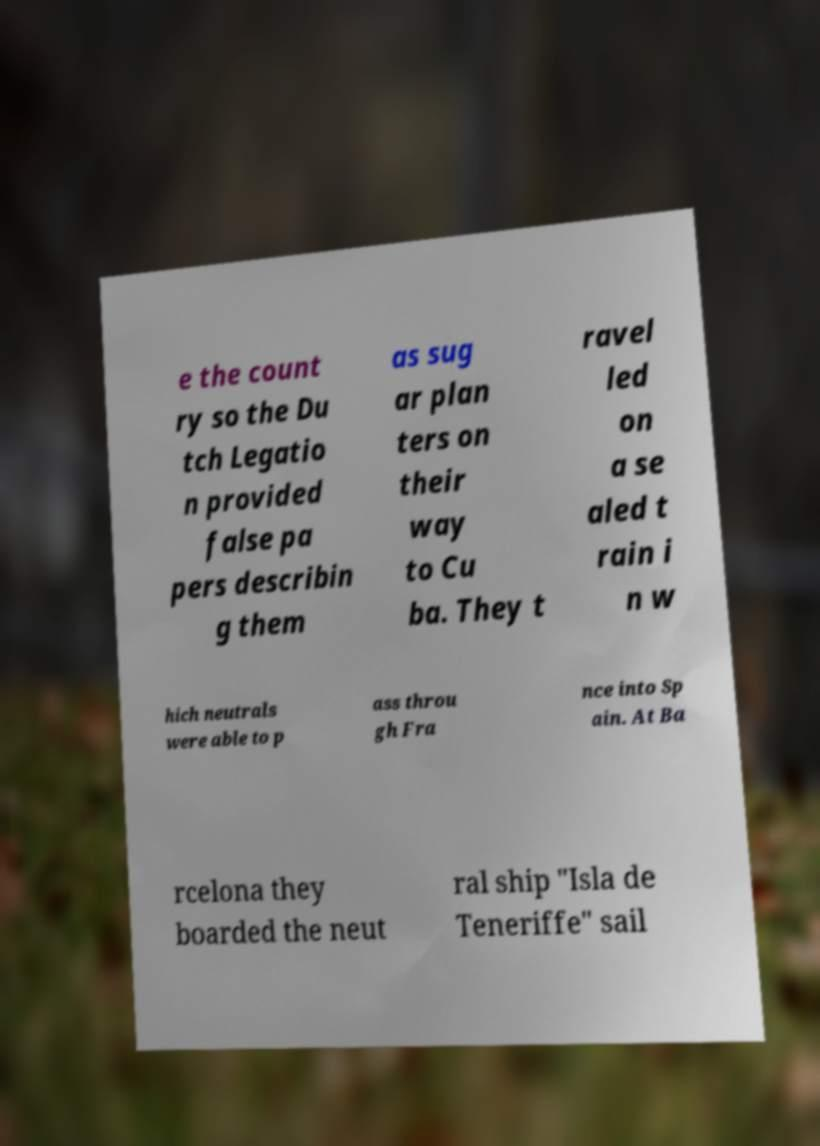Could you assist in decoding the text presented in this image and type it out clearly? e the count ry so the Du tch Legatio n provided false pa pers describin g them as sug ar plan ters on their way to Cu ba. They t ravel led on a se aled t rain i n w hich neutrals were able to p ass throu gh Fra nce into Sp ain. At Ba rcelona they boarded the neut ral ship "Isla de Teneriffe" sail 